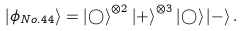Convert formula to latex. <formula><loc_0><loc_0><loc_500><loc_500>\left | \phi _ { N o . 4 4 } \right \rangle = \left | \bigcirc \right \rangle ^ { \otimes 2 } \left | + \right \rangle ^ { \otimes 3 } \left | \bigcirc \right \rangle \left | - \right \rangle .</formula> 